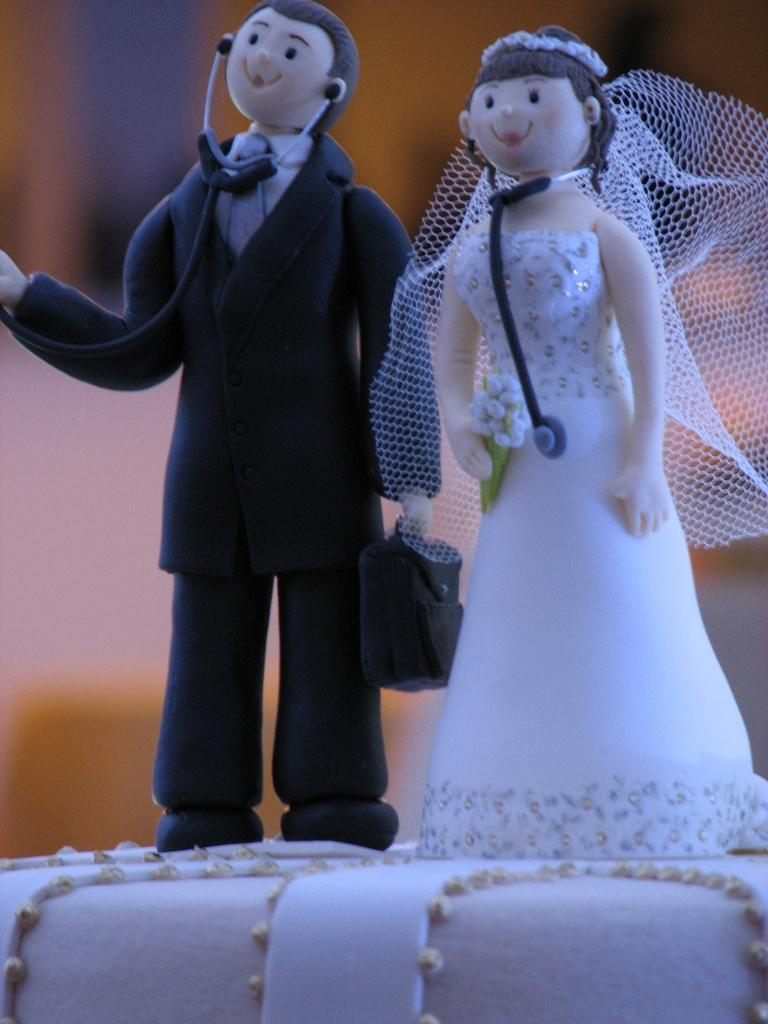What is the main subject of the image? There is a cake in the image. What are the two persons doing in the image? Two persons are standing with stethoscopes on the cake. What material are the stethoscopes made of? The stethoscopes are made of cake material. Can you describe the background of the image? The background of the image is blurred. Can you tell me how many veins are visible on the cake in the image? There are no veins visible on the cake in the image, as it is a cake with stethoscopes made of cake material. Is there a fly sitting on the cake in the image? There is no fly present on the cake in the image. 